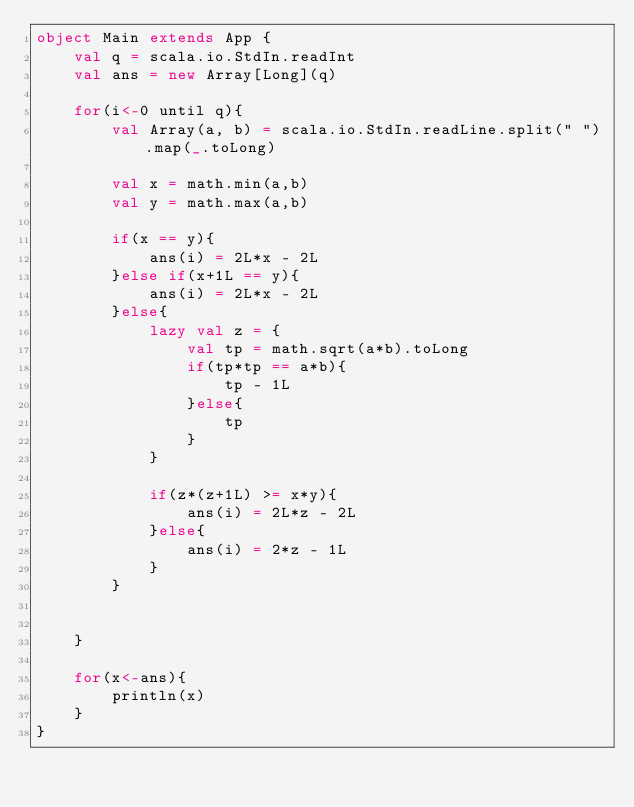Convert code to text. <code><loc_0><loc_0><loc_500><loc_500><_Scala_>object Main extends App {
	val q = scala.io.StdIn.readInt
	val ans = new Array[Long](q)

	for(i<-0 until q){
		val Array(a, b) = scala.io.StdIn.readLine.split(" ").map(_.toLong)

		val x = math.min(a,b)
		val y = math.max(a,b)

		if(x == y){
			ans(i) = 2L*x - 2L
		}else if(x+1L == y){
			ans(i) = 2L*x - 2L
		}else{
			lazy val z = {
				val tp = math.sqrt(a*b).toLong
				if(tp*tp == a*b){
					tp - 1L
				}else{
					tp
				}
			}

			if(z*(z+1L) >= x*y){
				ans(i) = 2L*z - 2L
			}else{
				ans(i) = 2*z - 1L
			}
		}

		
	}

	for(x<-ans){
		println(x)
	}
}</code> 